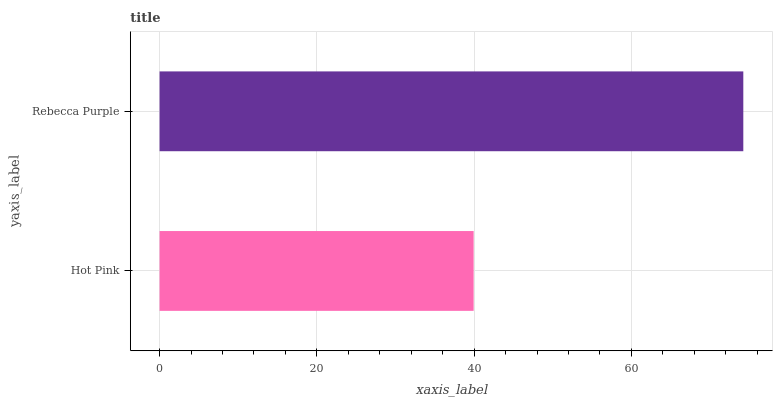Is Hot Pink the minimum?
Answer yes or no. Yes. Is Rebecca Purple the maximum?
Answer yes or no. Yes. Is Rebecca Purple the minimum?
Answer yes or no. No. Is Rebecca Purple greater than Hot Pink?
Answer yes or no. Yes. Is Hot Pink less than Rebecca Purple?
Answer yes or no. Yes. Is Hot Pink greater than Rebecca Purple?
Answer yes or no. No. Is Rebecca Purple less than Hot Pink?
Answer yes or no. No. Is Rebecca Purple the high median?
Answer yes or no. Yes. Is Hot Pink the low median?
Answer yes or no. Yes. Is Hot Pink the high median?
Answer yes or no. No. Is Rebecca Purple the low median?
Answer yes or no. No. 